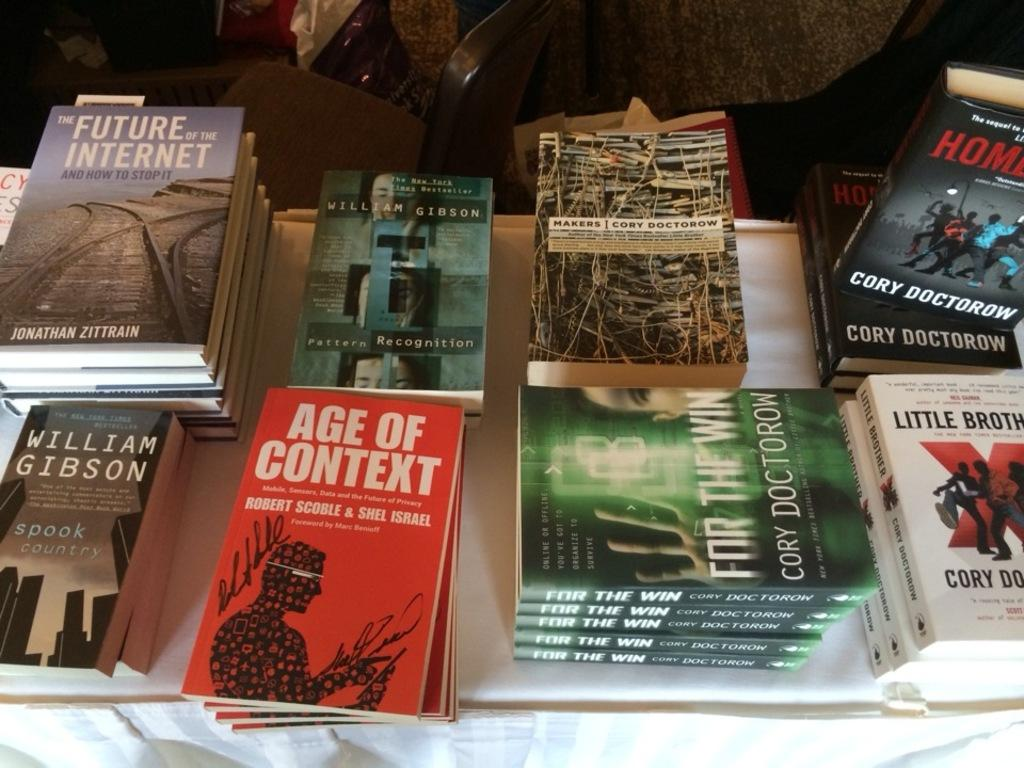Provide a one-sentence caption for the provided image. A number of nbooks stacked on a table including one called Age of Context and another by William Gibson. 